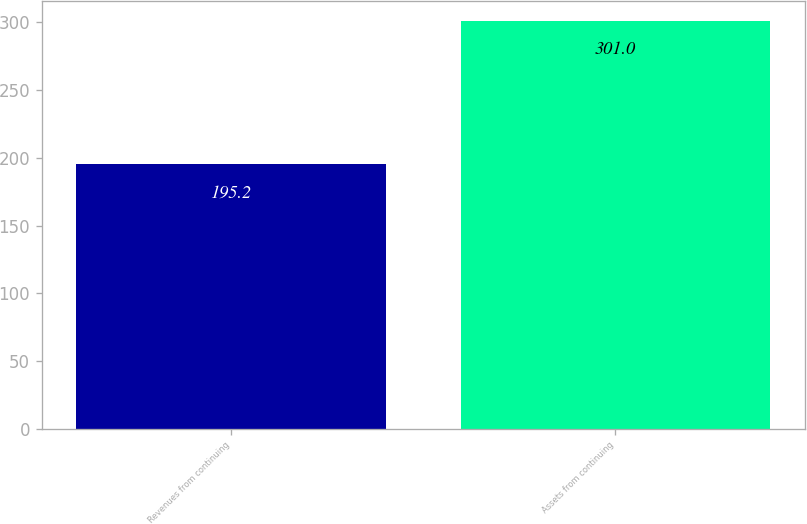Convert chart to OTSL. <chart><loc_0><loc_0><loc_500><loc_500><bar_chart><fcel>Revenues from continuing<fcel>Assets from continuing<nl><fcel>195.2<fcel>301<nl></chart> 